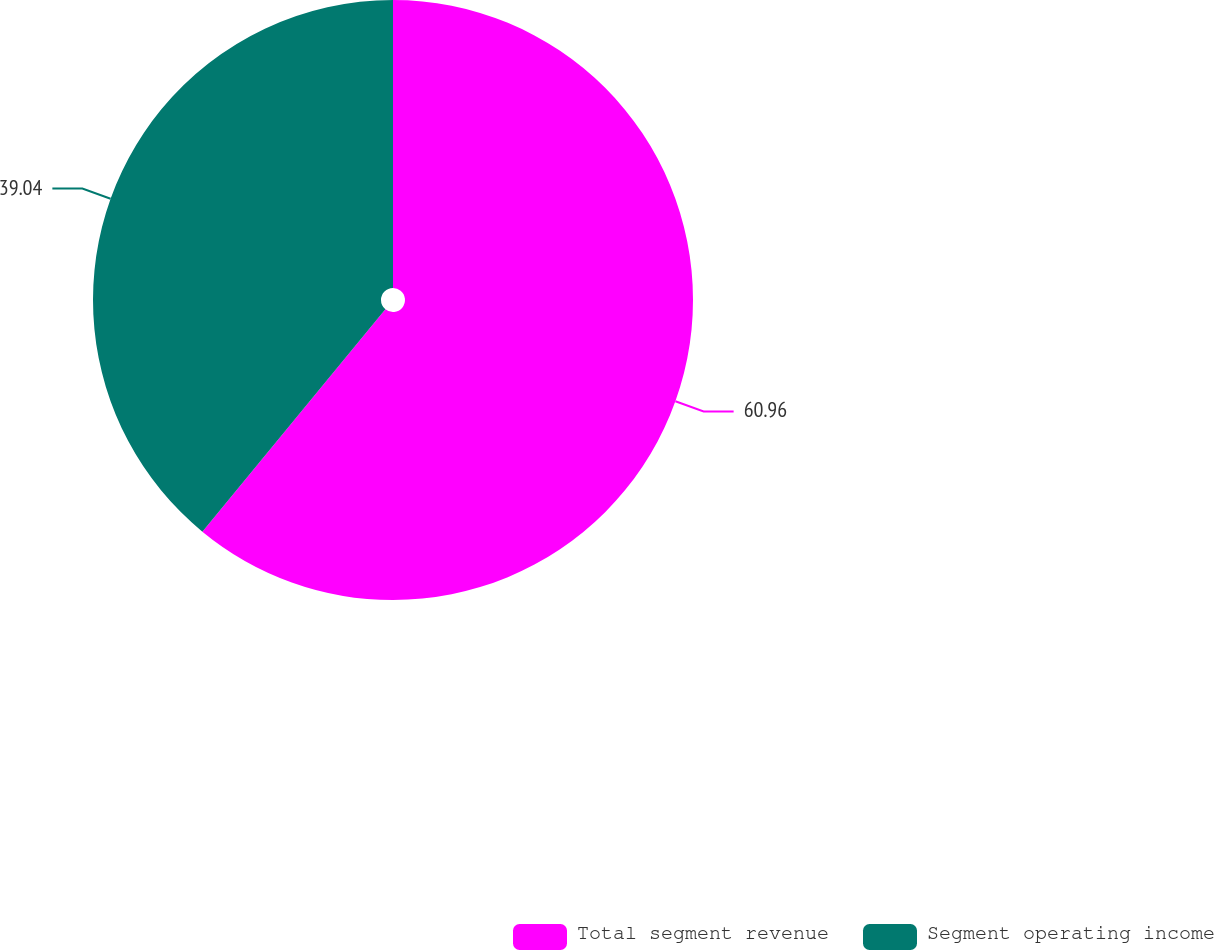Convert chart to OTSL. <chart><loc_0><loc_0><loc_500><loc_500><pie_chart><fcel>Total segment revenue<fcel>Segment operating income<nl><fcel>60.96%<fcel>39.04%<nl></chart> 